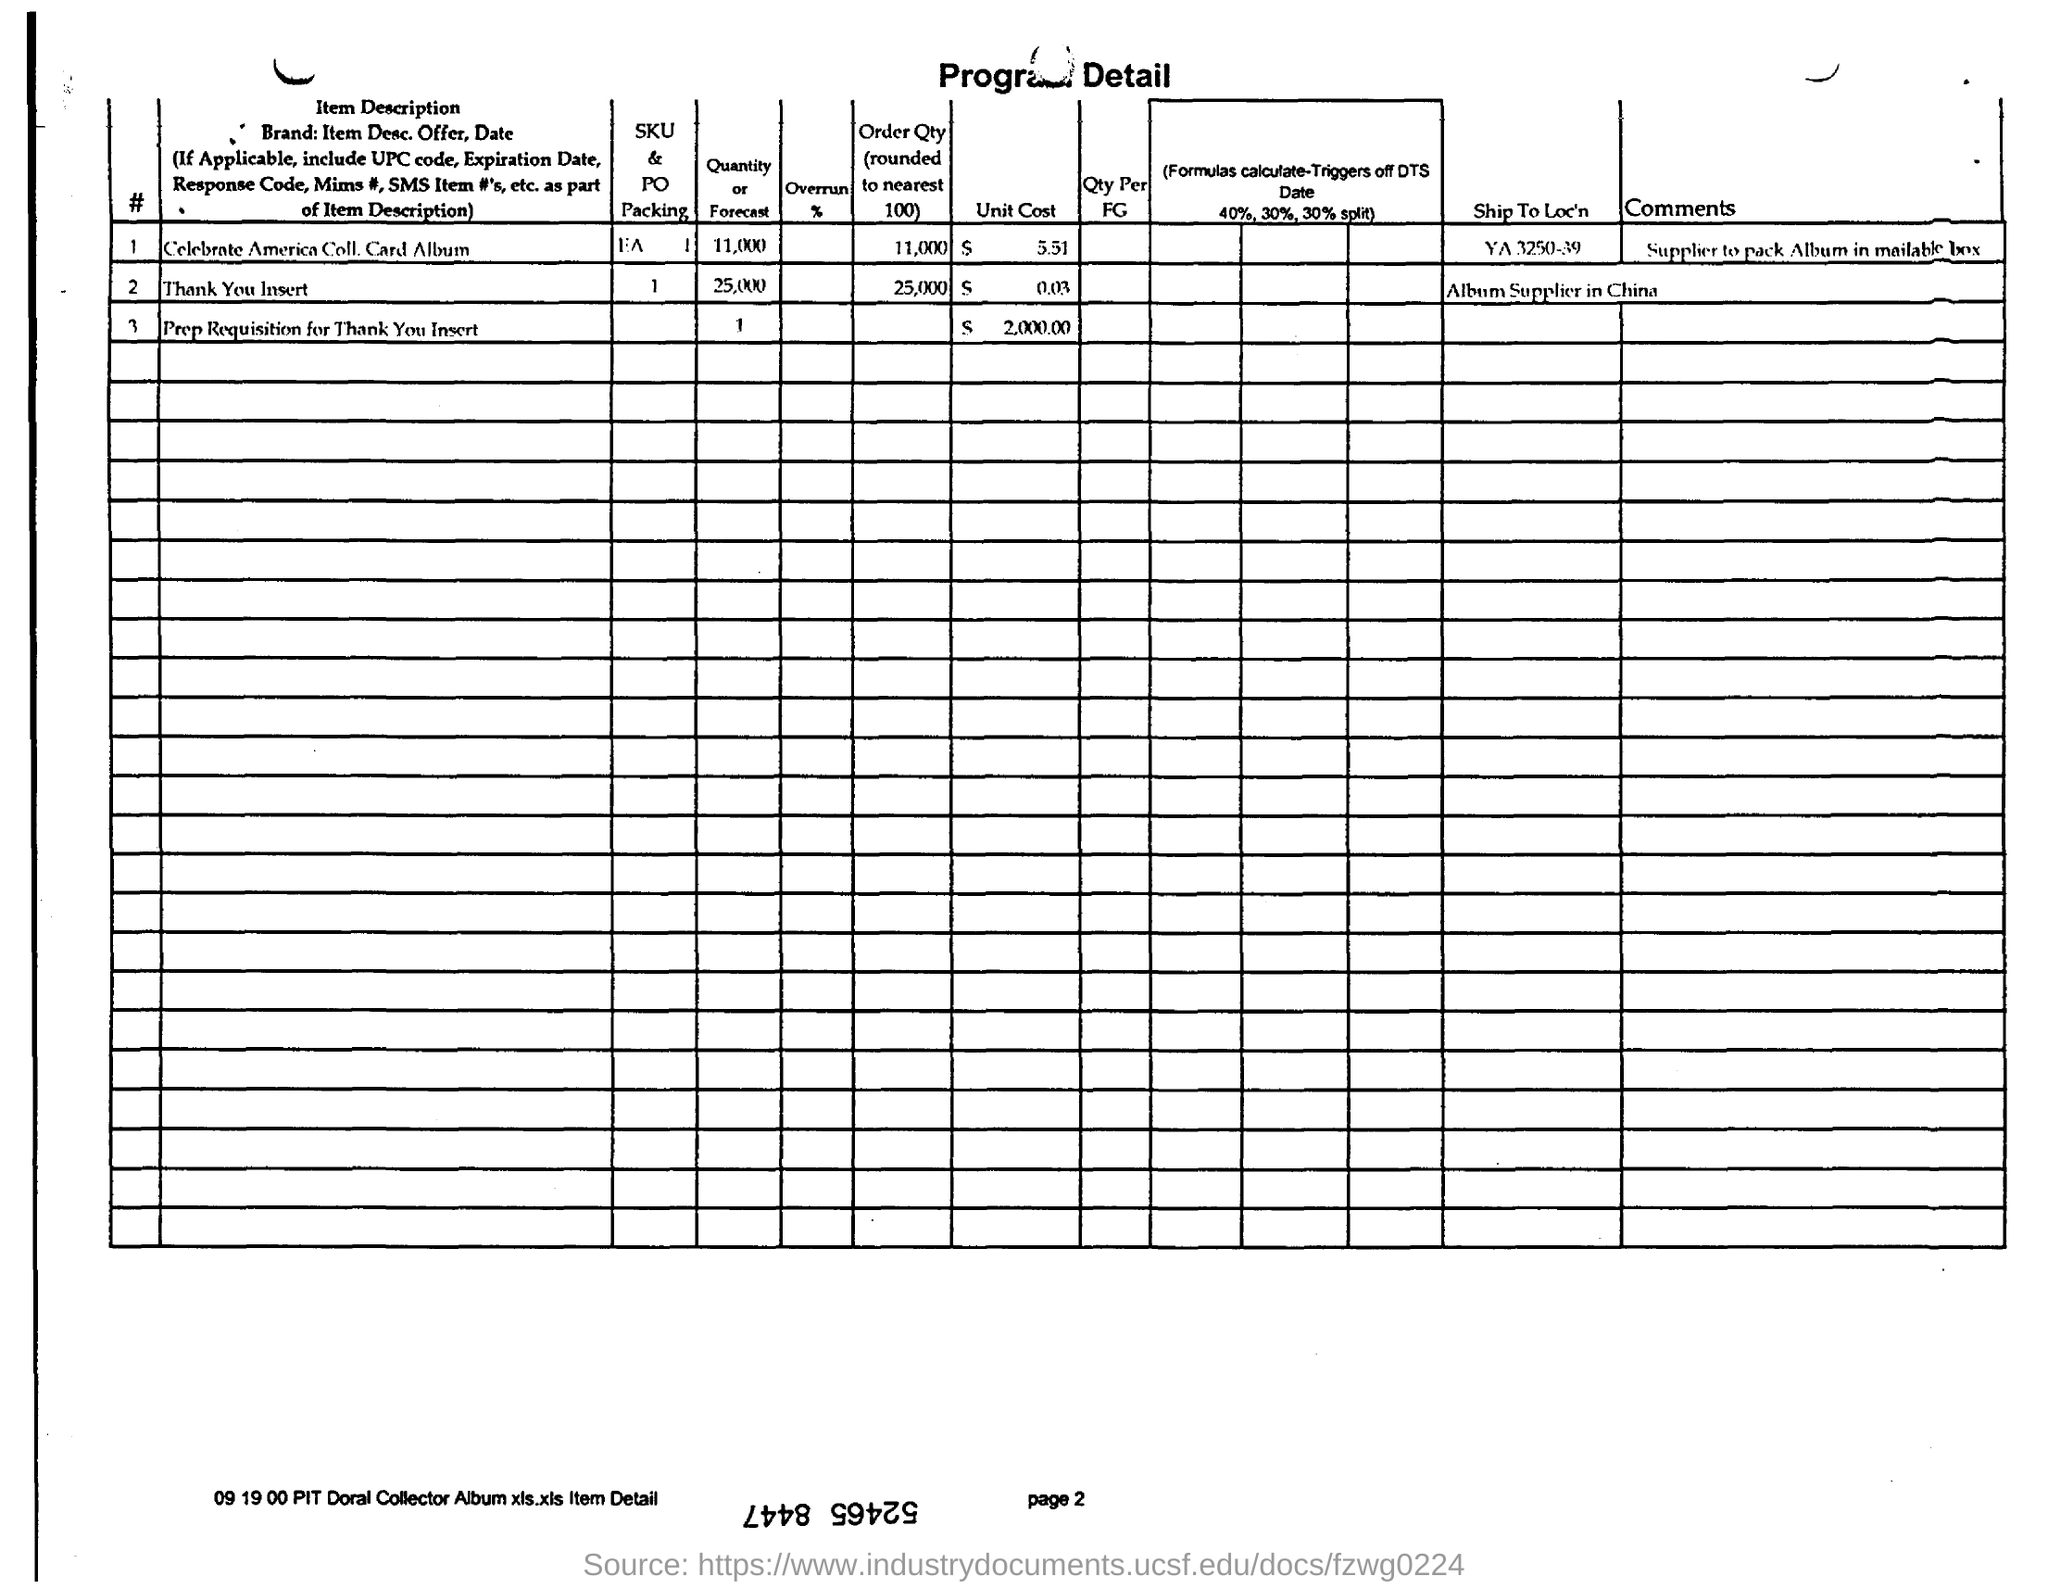Give some essential details in this illustration. The unit cost of the Celebrate America Collector's Card Album is $5.51. The order quantity for "Thank You Insert" is 25,000. 